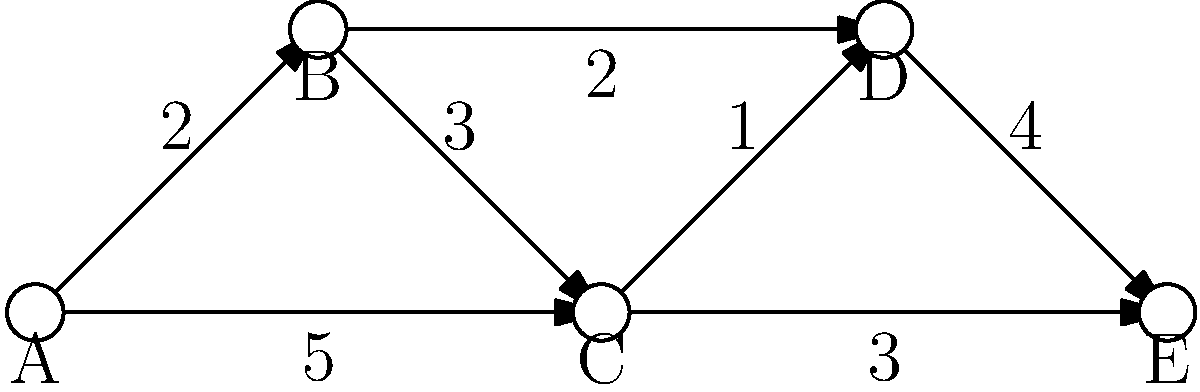In the software-defined network (SDN) topology shown above, what is the most efficient route from node A to node E in terms of minimizing the total weight (representing network latency)? How does this routing decision demonstrate the advantage of SDN over traditional networking? To solve this problem and understand the advantages of SDN, let's follow these steps:

1. Identify all possible paths from A to E:
   - A -> B -> C -> D -> E
   - A -> B -> D -> E
   - A -> C -> D -> E
   - A -> C -> E

2. Calculate the total weight for each path:
   - A -> B -> C -> D -> E: 2 + 3 + 1 + 4 = 10
   - A -> B -> D -> E: 2 + 2 + 4 = 8
   - A -> C -> D -> E: 5 + 1 + 4 = 10
   - A -> C -> E: 5 + 3 = 8

3. Determine the most efficient route:
   The paths A -> B -> D -> E and A -> C -> E both have the lowest total weight of 8.

4. SDN advantage:
   In traditional networking, routers make decisions based on local information and pre-configured rules. They might not always choose the most efficient global path.

   SDN, however, provides a centralized control plane that can:
   a) Have a global view of the network topology and current conditions.
   b) Dynamically calculate the most efficient path based on various metrics (e.g., latency, bandwidth, congestion).
   c) Quickly update routing tables across all devices to implement the optimal path.

   In this case, an SDN controller could:
   - Recognize that there are two equally efficient paths (A -> B -> D -> E and A -> C -> E).
   - Choose one based on additional factors like current traffic load or link utilization.
   - Dynamically update the routing tables of all involved switches to implement this path.
   - Quickly change the route if network conditions change, ensuring continued optimal performance.

This flexibility and global optimization capability demonstrate key advantages of SDN over traditional networking approaches.
Answer: A -> B -> D -> E or A -> C -> E (weight: 8); SDN enables global view and dynamic optimization. 